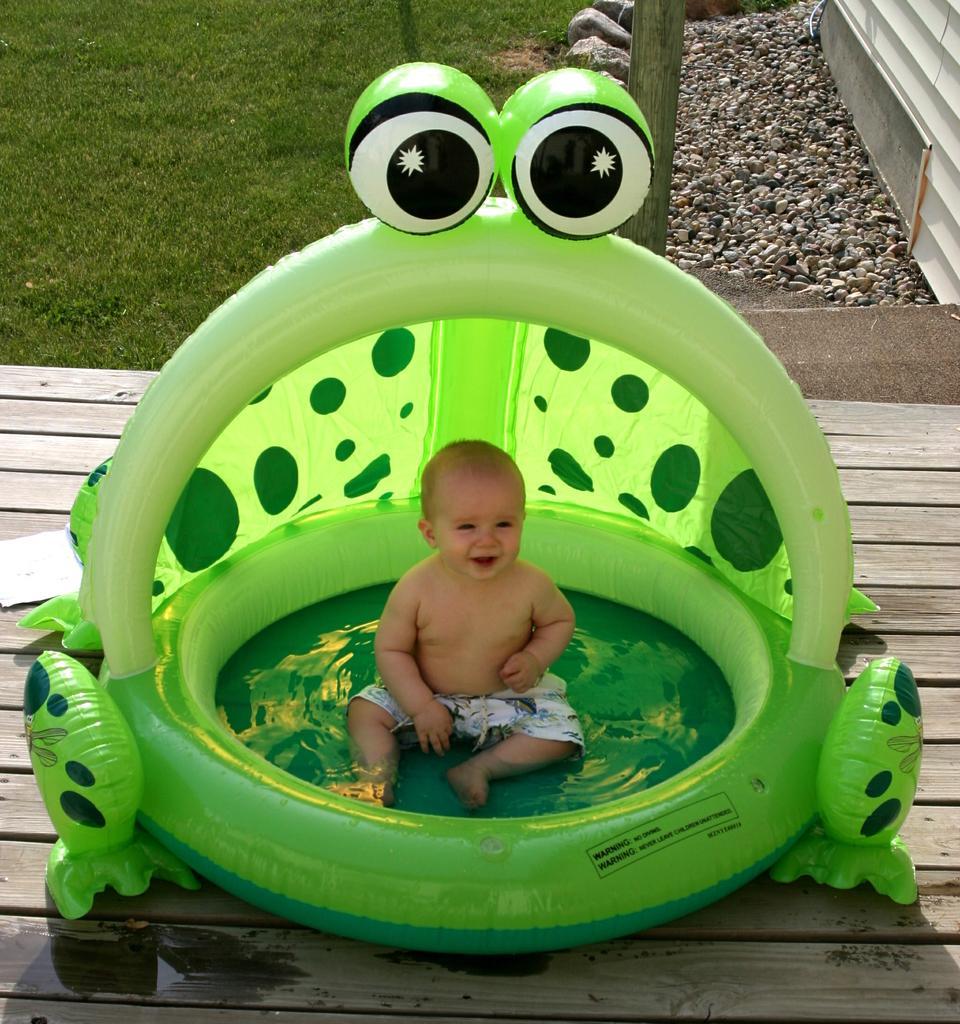Please provide a concise description of this image. There is a baby smiling and sitting in the inflatable green color frog ring. Which is on the on the wooden surface. In the background, there is grass on the ground, there are stones near rocks arranged and there is wall. 